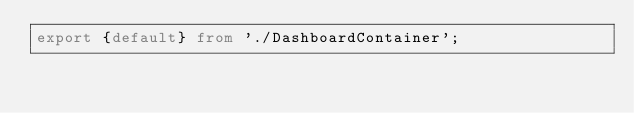Convert code to text. <code><loc_0><loc_0><loc_500><loc_500><_TypeScript_>export {default} from './DashboardContainer';
</code> 